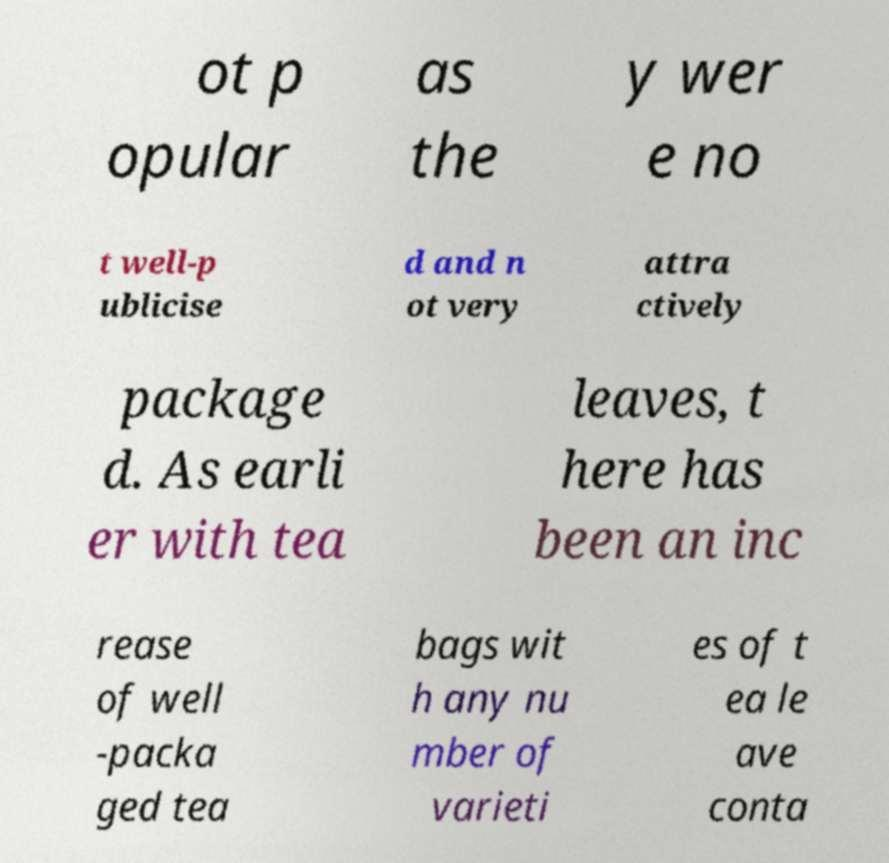Can you accurately transcribe the text from the provided image for me? ot p opular as the y wer e no t well-p ublicise d and n ot very attra ctively package d. As earli er with tea leaves, t here has been an inc rease of well -packa ged tea bags wit h any nu mber of varieti es of t ea le ave conta 